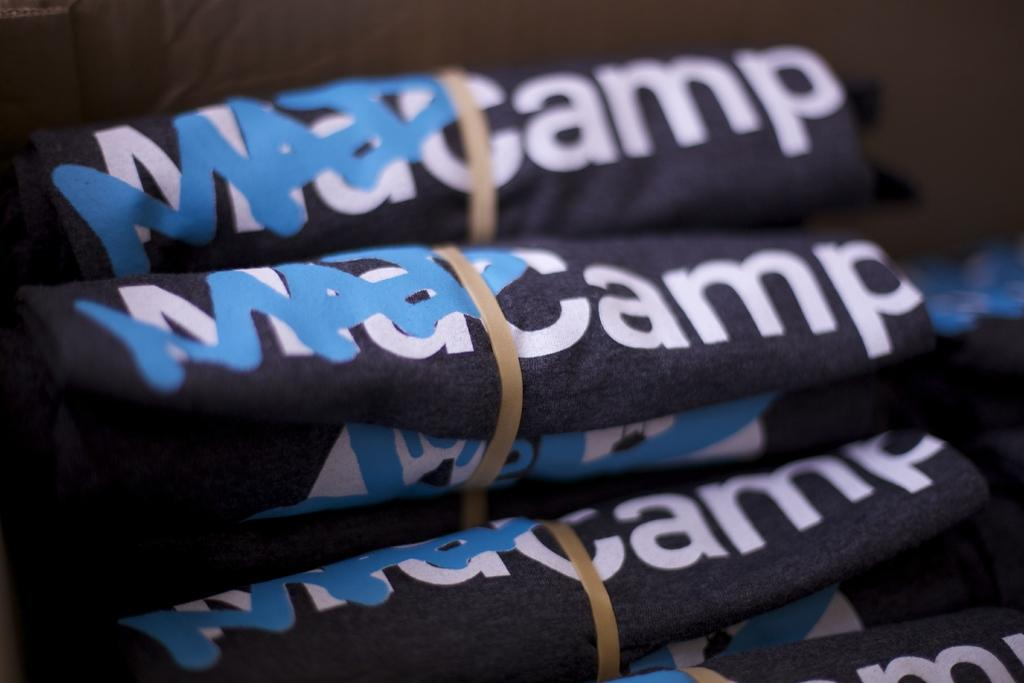What type of clothes are visible in the image? There are clothes with text in the image. What can be observed about the background of the image? The background of the image is dark. Can you see an example of the text bursting into laughter in the image? There is no text or any indication of laughter in the image; it only features clothes with text and a dark background. 